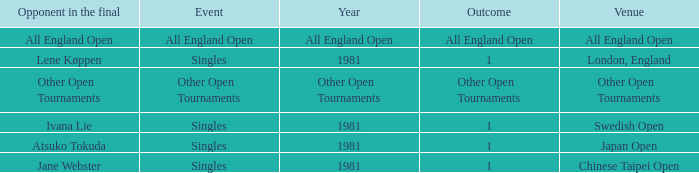What is the Outcome when All England Open is the Opponent in the final? All England Open. 